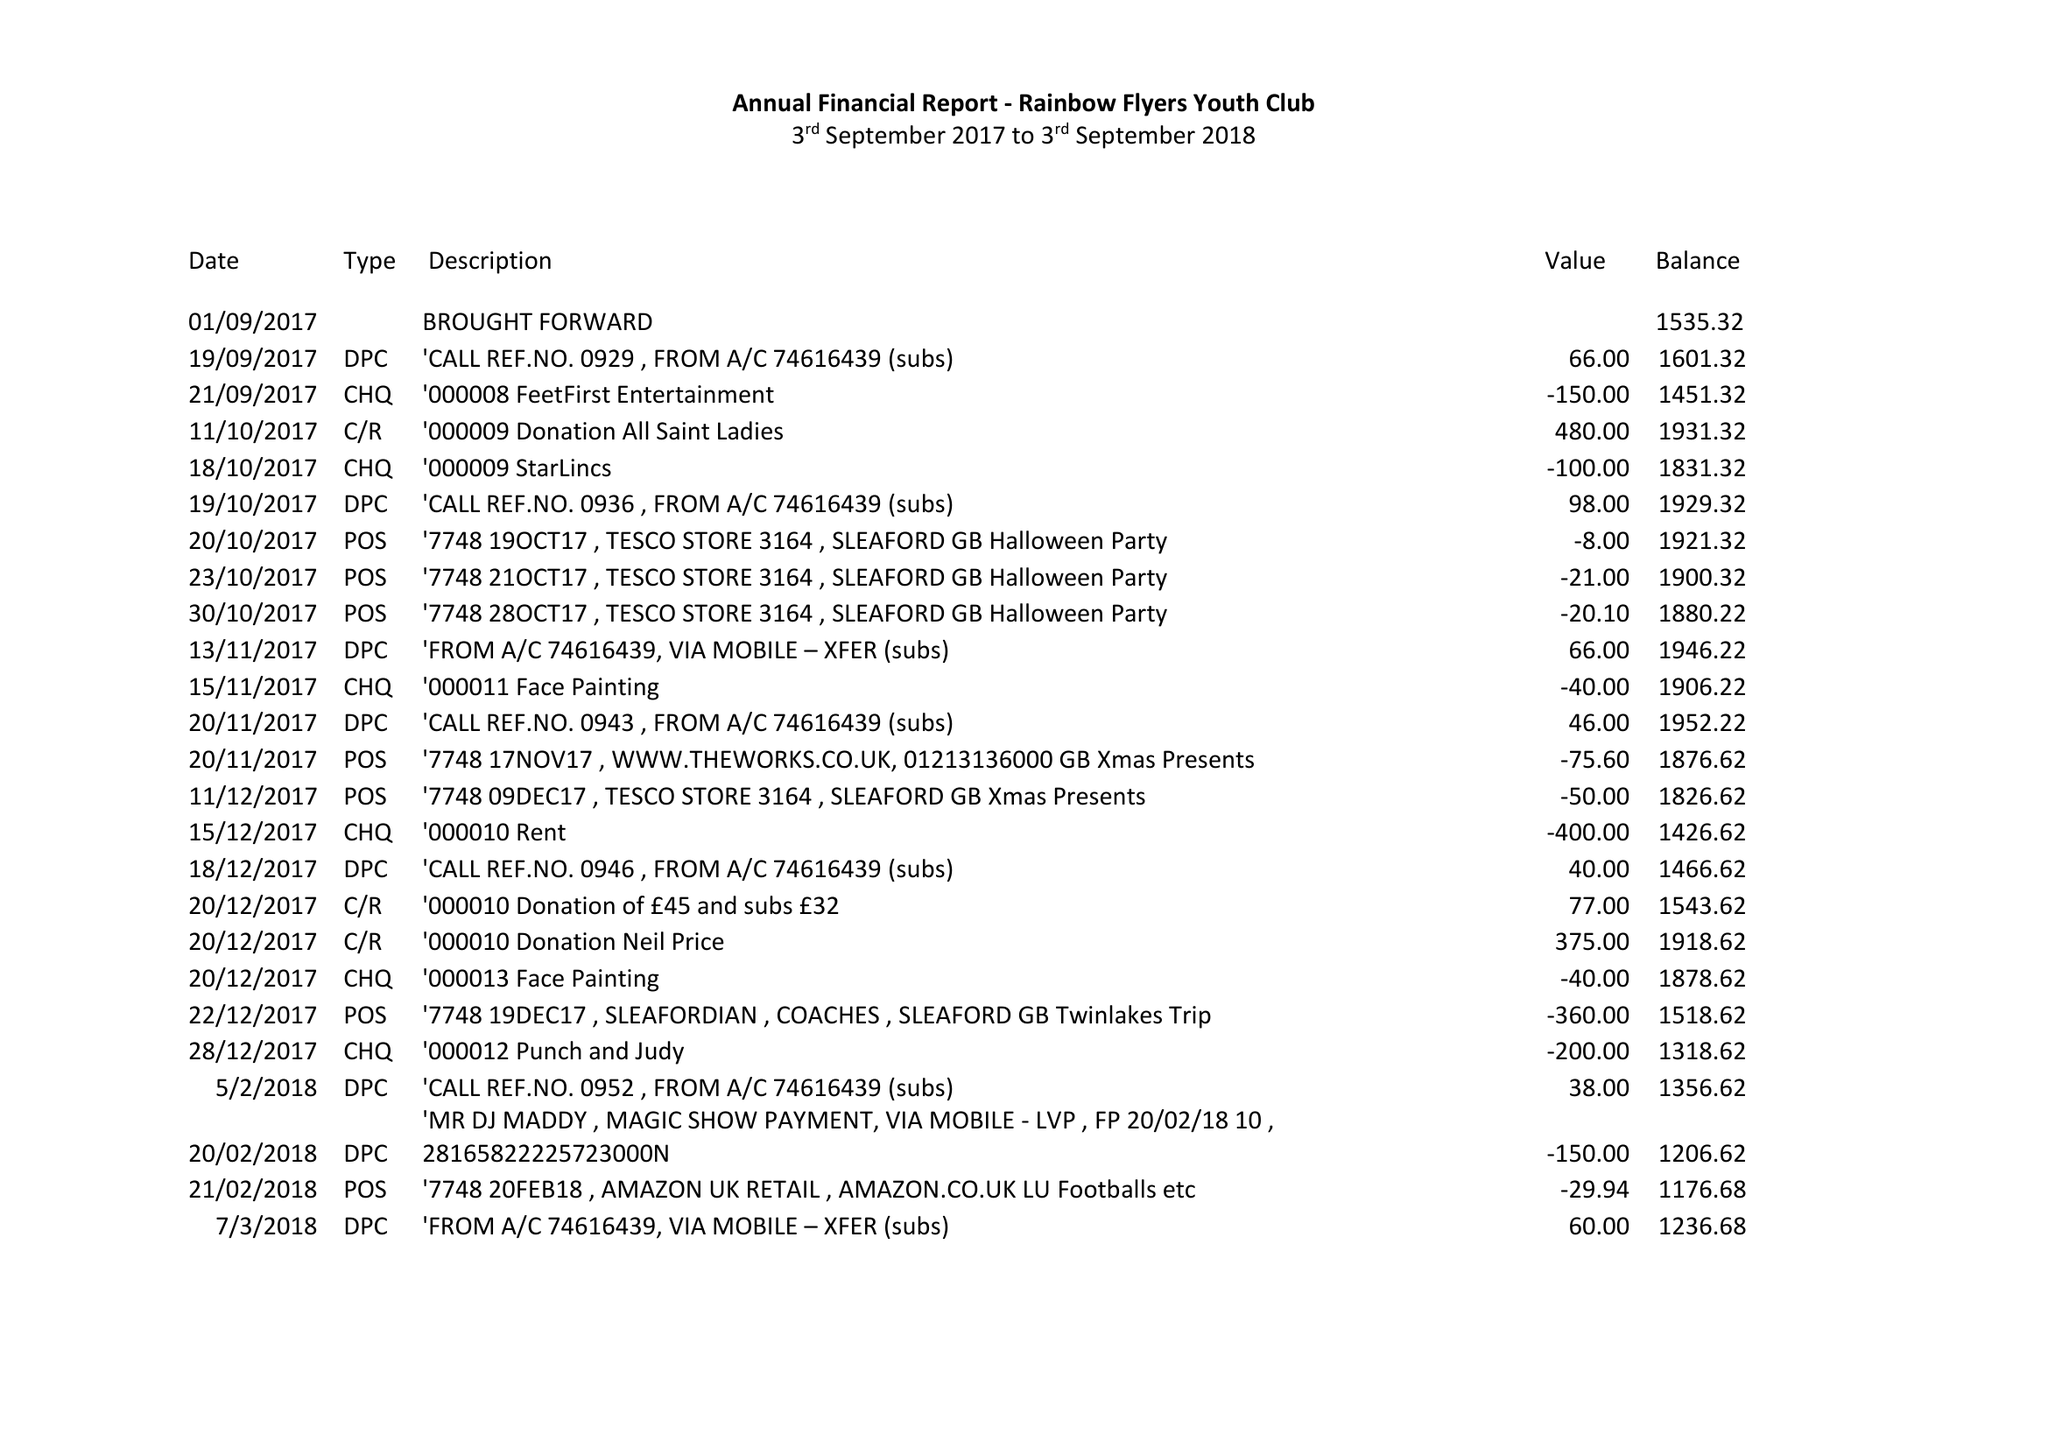What is the value for the spending_annually_in_british_pounds?
Answer the question using a single word or phrase. 2689.28 